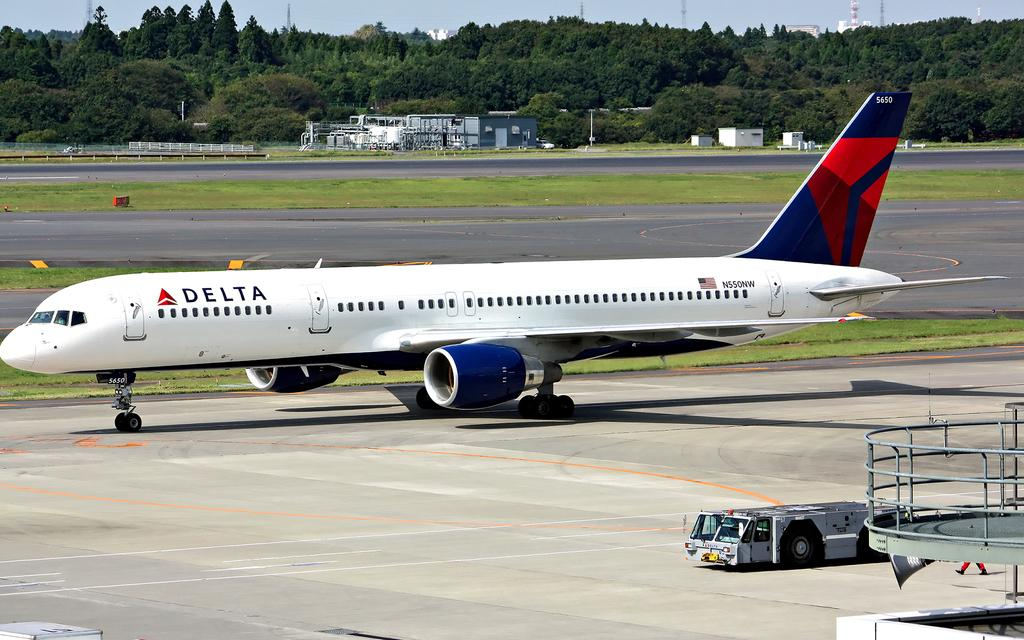<image>
Present a compact description of the photo's key features. A Delta plane is waiting to be boarding 